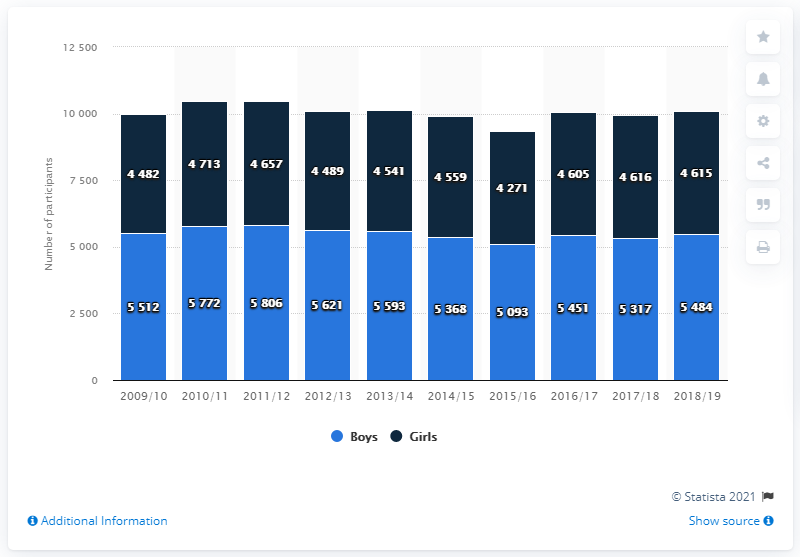Identify some key points in this picture. During the 2018/2019 season, 5484 boys participated in the high school alpine skiing program. 